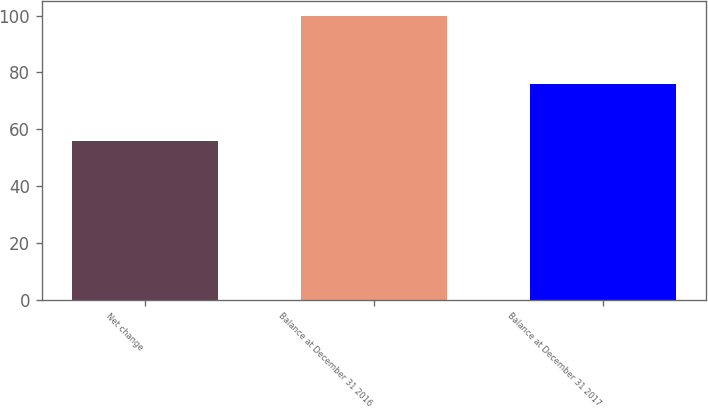<chart> <loc_0><loc_0><loc_500><loc_500><bar_chart><fcel>Net change<fcel>Balance at December 31 2016<fcel>Balance at December 31 2017<nl><fcel>56<fcel>100<fcel>76<nl></chart> 